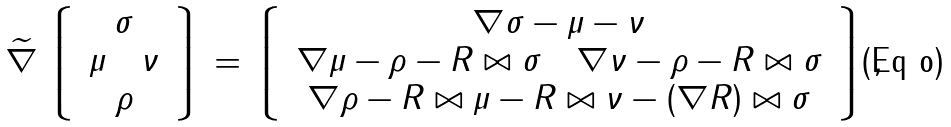Convert formula to latex. <formula><loc_0><loc_0><loc_500><loc_500>\widetilde { \nabla } \left \lgroup \, \begin{array} c \sigma \\ \mu \quad \nu \\ \rho \end{array} \, \right \rgroup = \left \lgroup \, \begin{array} c \nabla \sigma - \mu - \nu \\ \nabla \mu - \rho - R \bowtie \sigma \quad \nabla \nu - \rho - R \bowtie \sigma \\ \nabla \rho - R \bowtie \mu - R \bowtie \nu - ( \nabla R ) \bowtie \sigma \end{array} \, \right \rgroup ,</formula> 